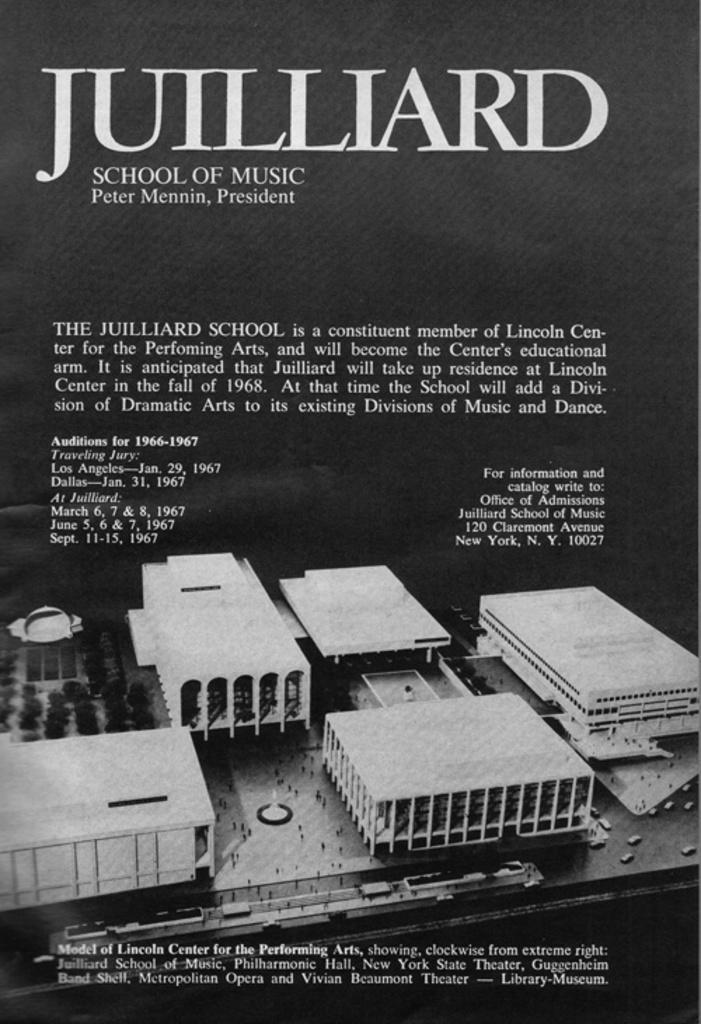In one or two sentences, can you explain what this image depicts? This image contains a poster having few buildings , cars and trees. Top of image there is some text. In between the buildings there are few persons. On road there are few vehicles. Bottom of image there is some text. 